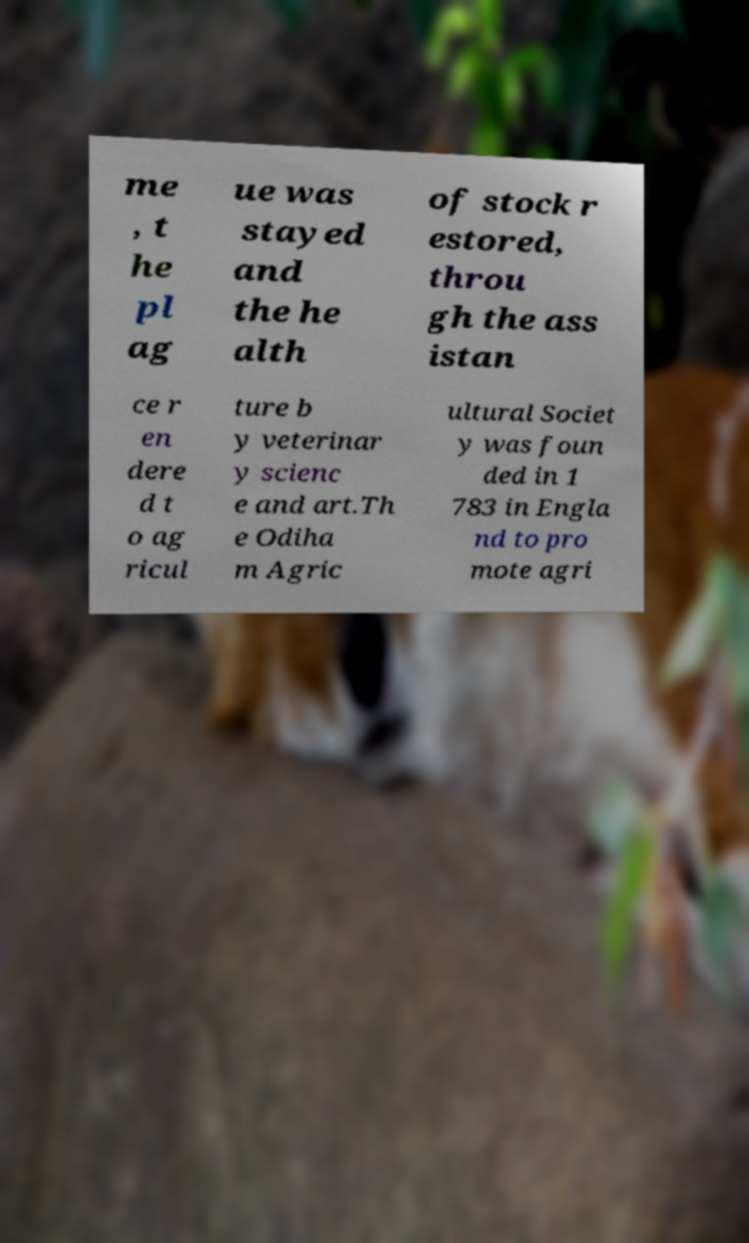Can you read and provide the text displayed in the image?This photo seems to have some interesting text. Can you extract and type it out for me? me , t he pl ag ue was stayed and the he alth of stock r estored, throu gh the ass istan ce r en dere d t o ag ricul ture b y veterinar y scienc e and art.Th e Odiha m Agric ultural Societ y was foun ded in 1 783 in Engla nd to pro mote agri 